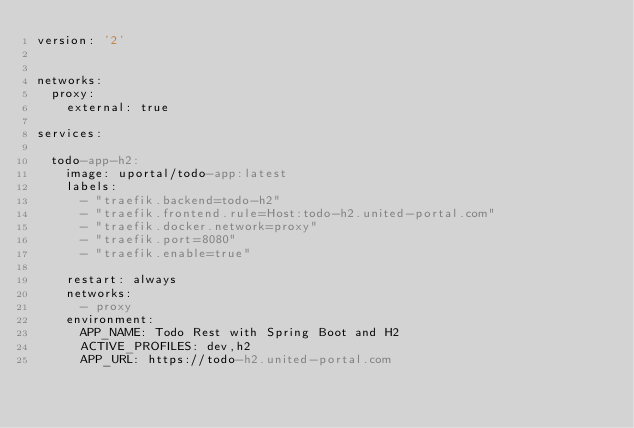<code> <loc_0><loc_0><loc_500><loc_500><_YAML_>version: '2'


networks:
  proxy:
    external: true

services:

  todo-app-h2:
    image: uportal/todo-app:latest
    labels:
      - "traefik.backend=todo-h2"
      - "traefik.frontend.rule=Host:todo-h2.united-portal.com"
      - "traefik.docker.network=proxy"
      - "traefik.port=8080"
      - "traefik.enable=true"

    restart: always
    networks:
      - proxy
    environment:
      APP_NAME: Todo Rest with Spring Boot and H2
      ACTIVE_PROFILES: dev,h2
      APP_URL: https://todo-h2.united-portal.com
</code> 